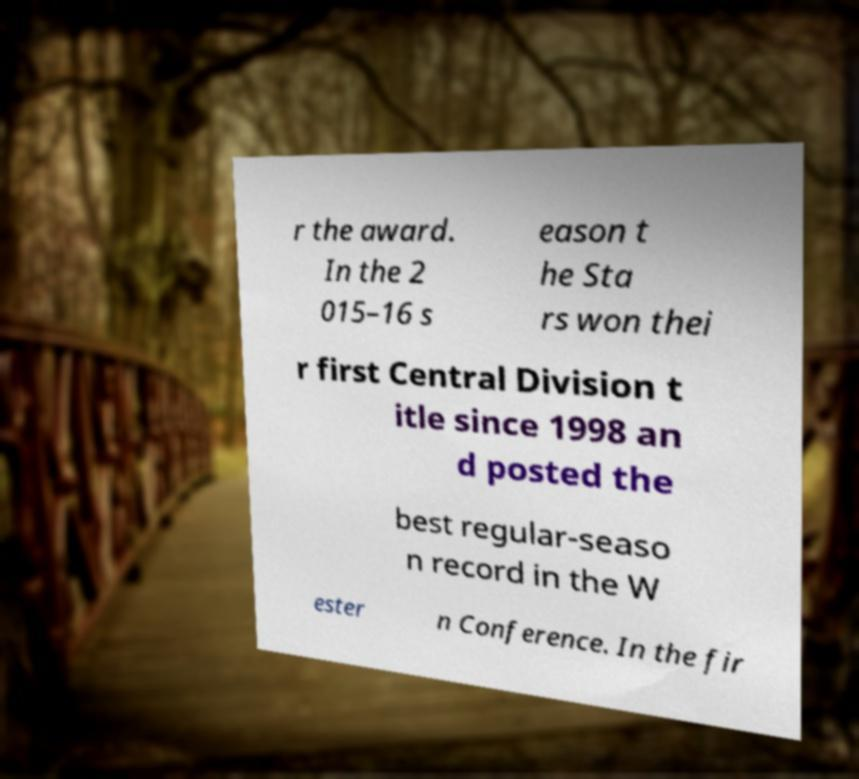Could you extract and type out the text from this image? r the award. In the 2 015–16 s eason t he Sta rs won thei r first Central Division t itle since 1998 an d posted the best regular-seaso n record in the W ester n Conference. In the fir 